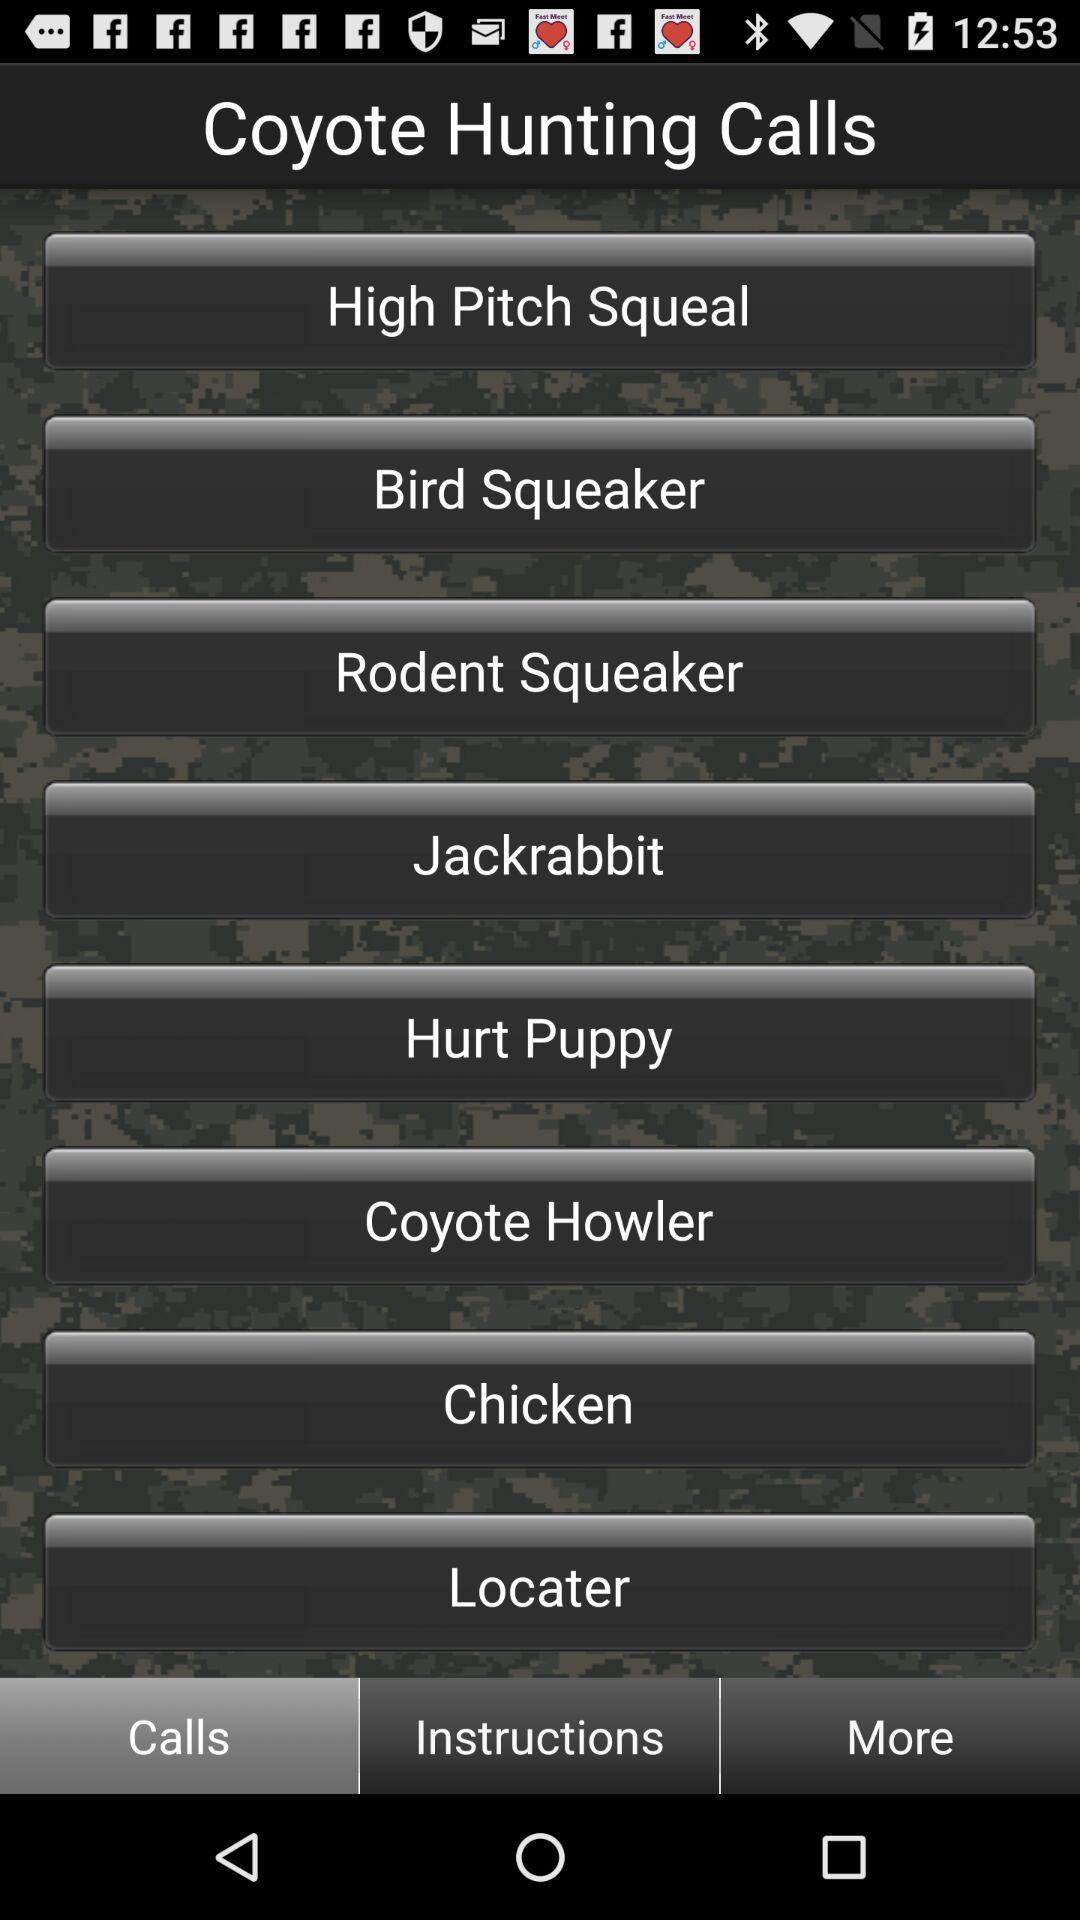How many coyote hunting calls are there in total?
When the provided information is insufficient, respond with <no answer>. <no answer> 